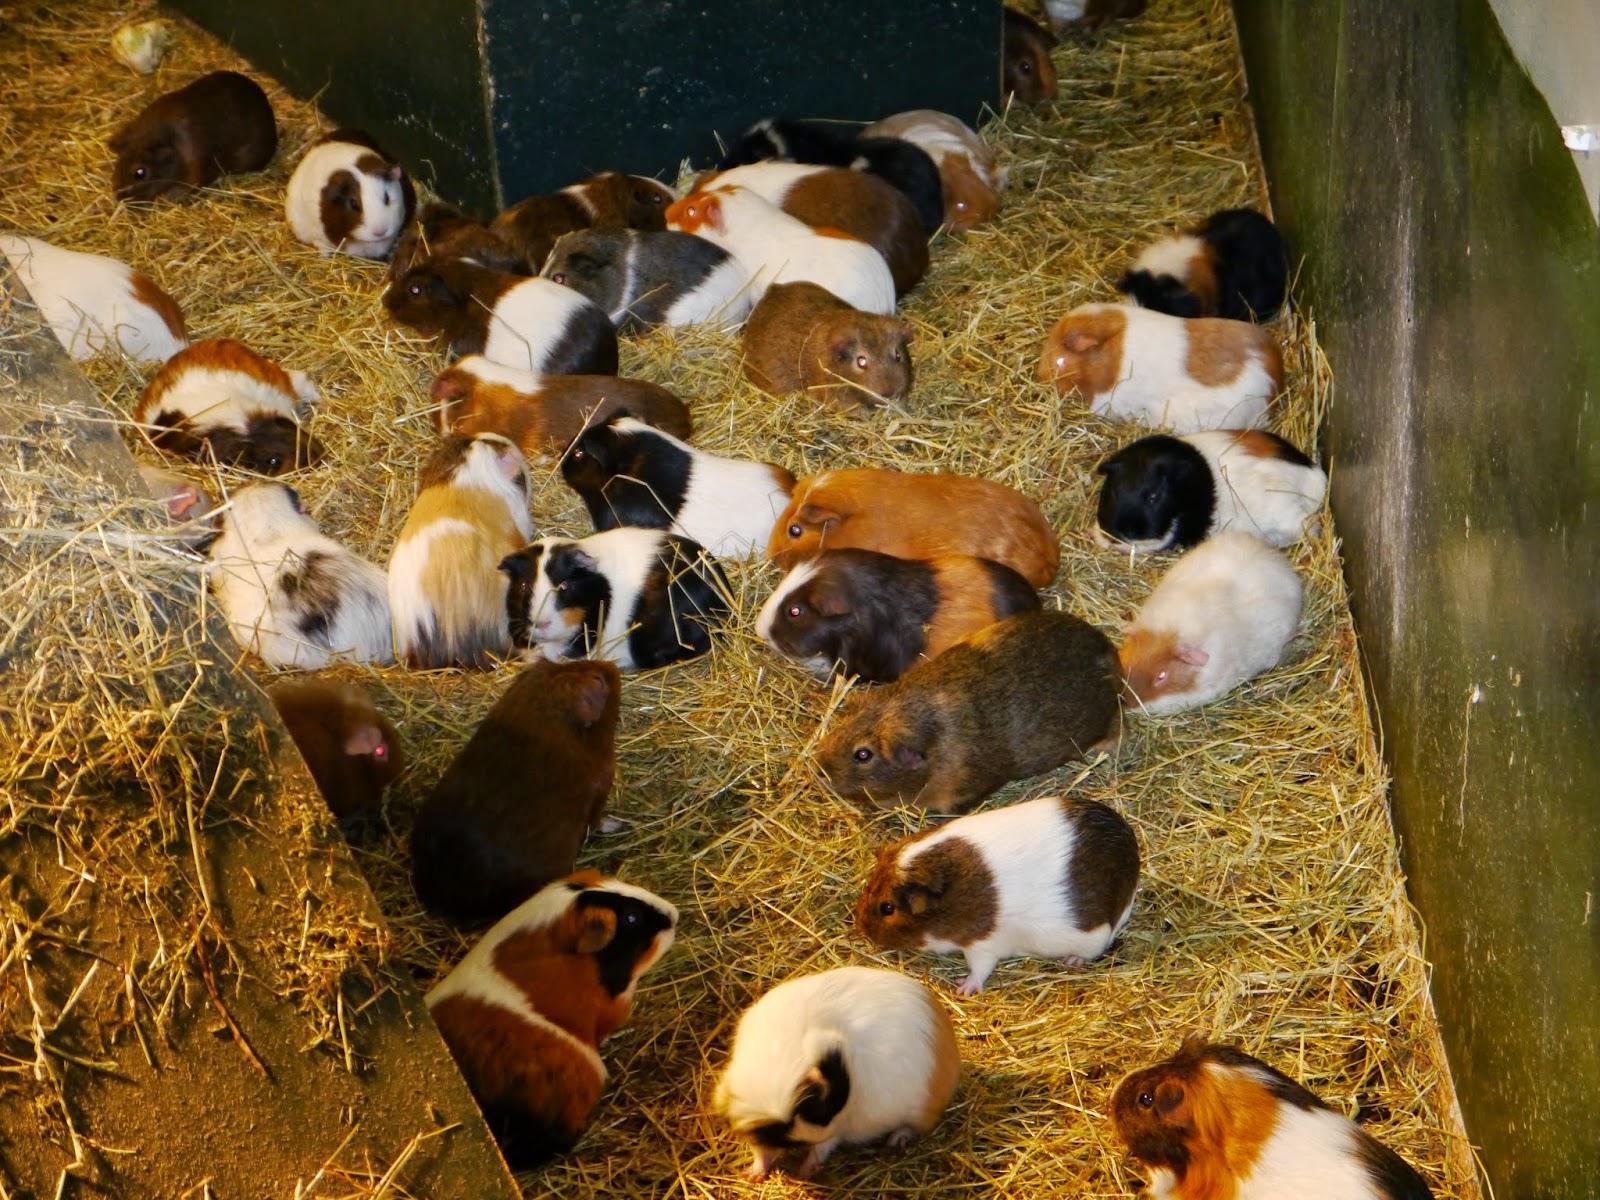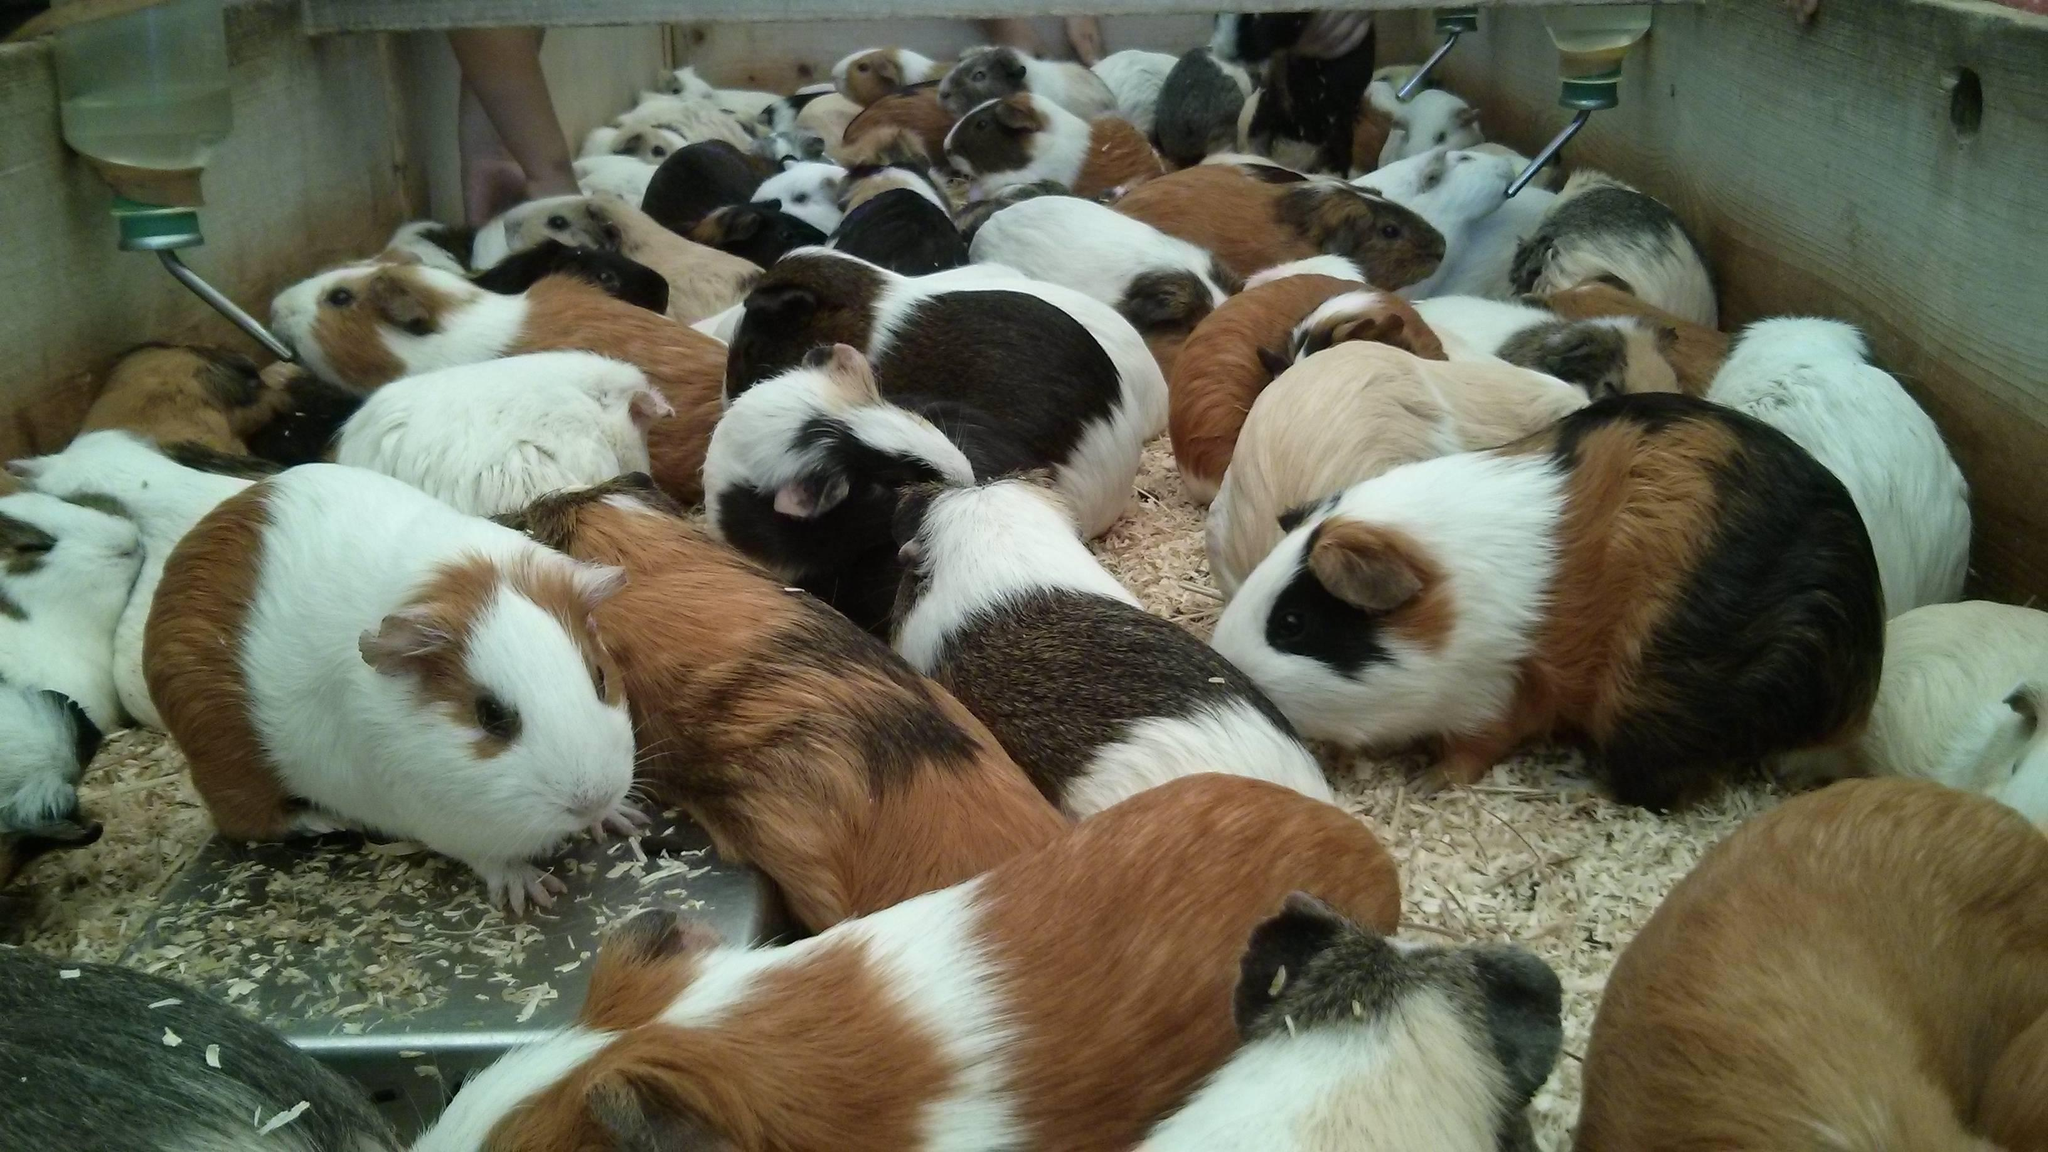The first image is the image on the left, the second image is the image on the right. Evaluate the accuracy of this statement regarding the images: "Some of the animals are sitting in a grassy area in one of the images.". Is it true? Answer yes or no. No. The first image is the image on the left, the second image is the image on the right. For the images displayed, is the sentence "An image shows guinea pigs clustered around a pile of something that is brighter in color than the rest of the ground area." factually correct? Answer yes or no. No. 